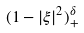<formula> <loc_0><loc_0><loc_500><loc_500>( 1 - | \xi | ^ { 2 } ) _ { + } ^ { \delta }</formula> 